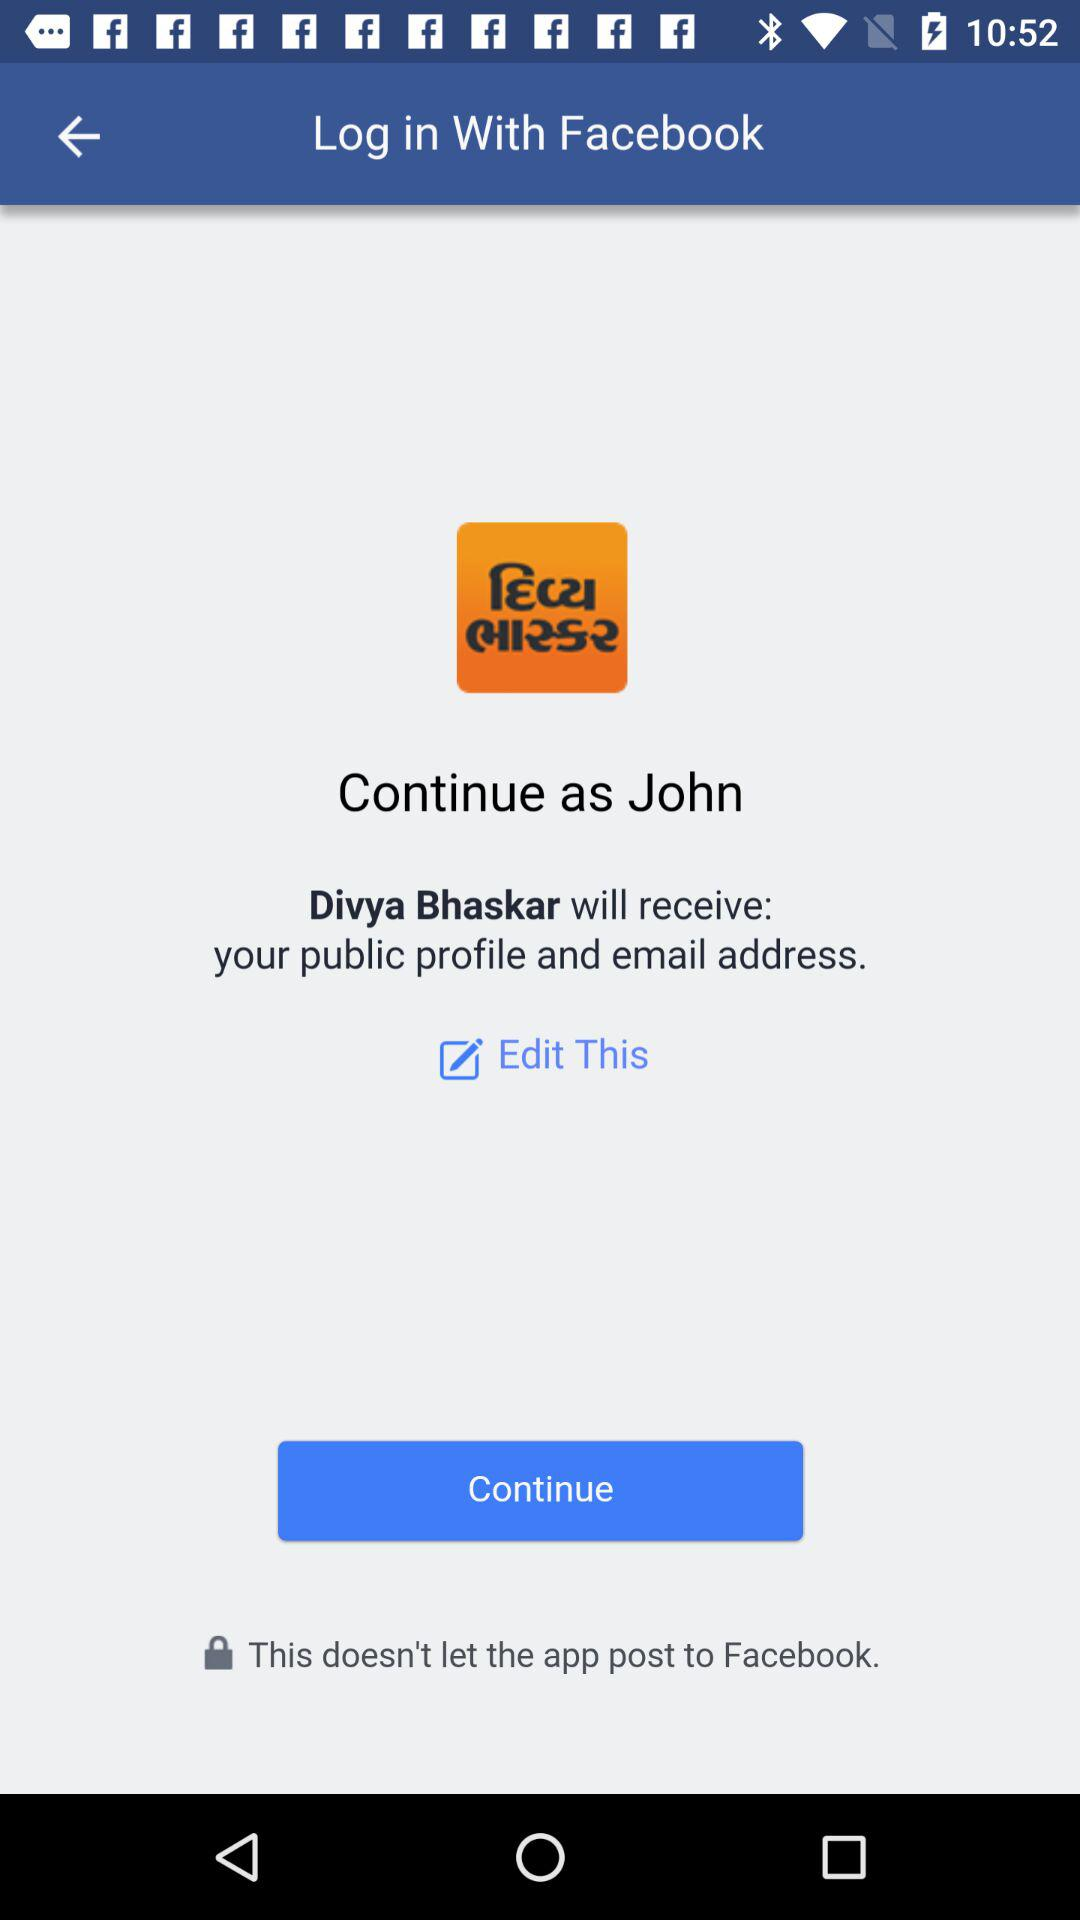What app will receive our email address? The app is "Divya Bhaskar". 